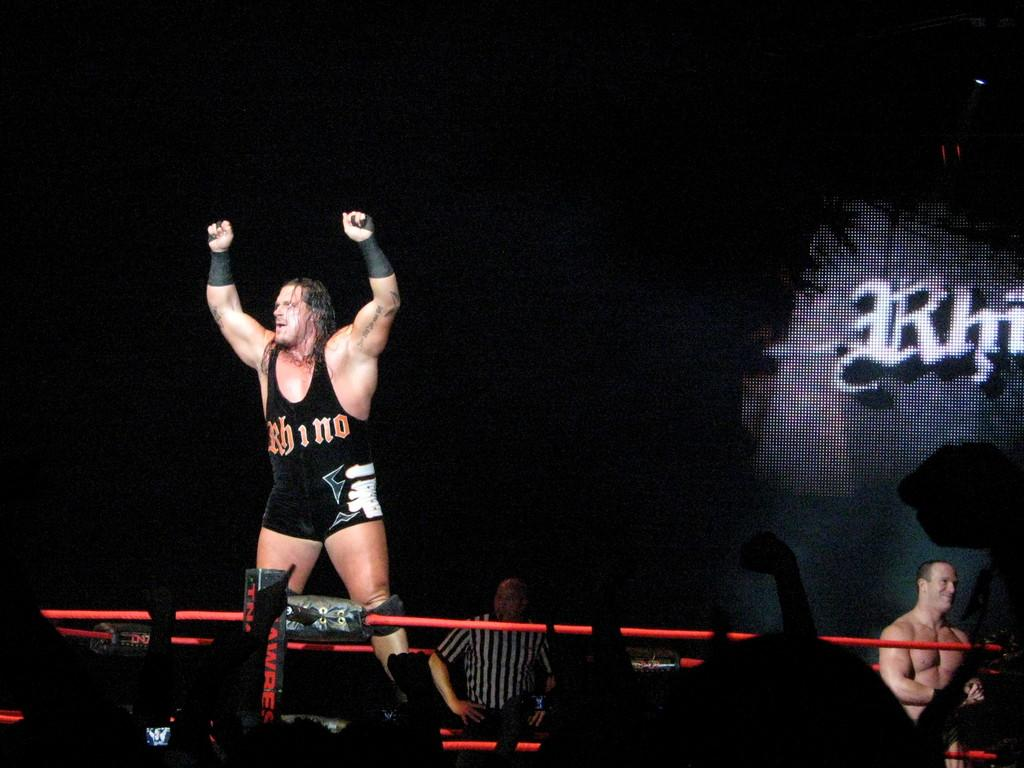<image>
Render a clear and concise summary of the photo. a boxer wearing a uniform that says 'rhino' on it 